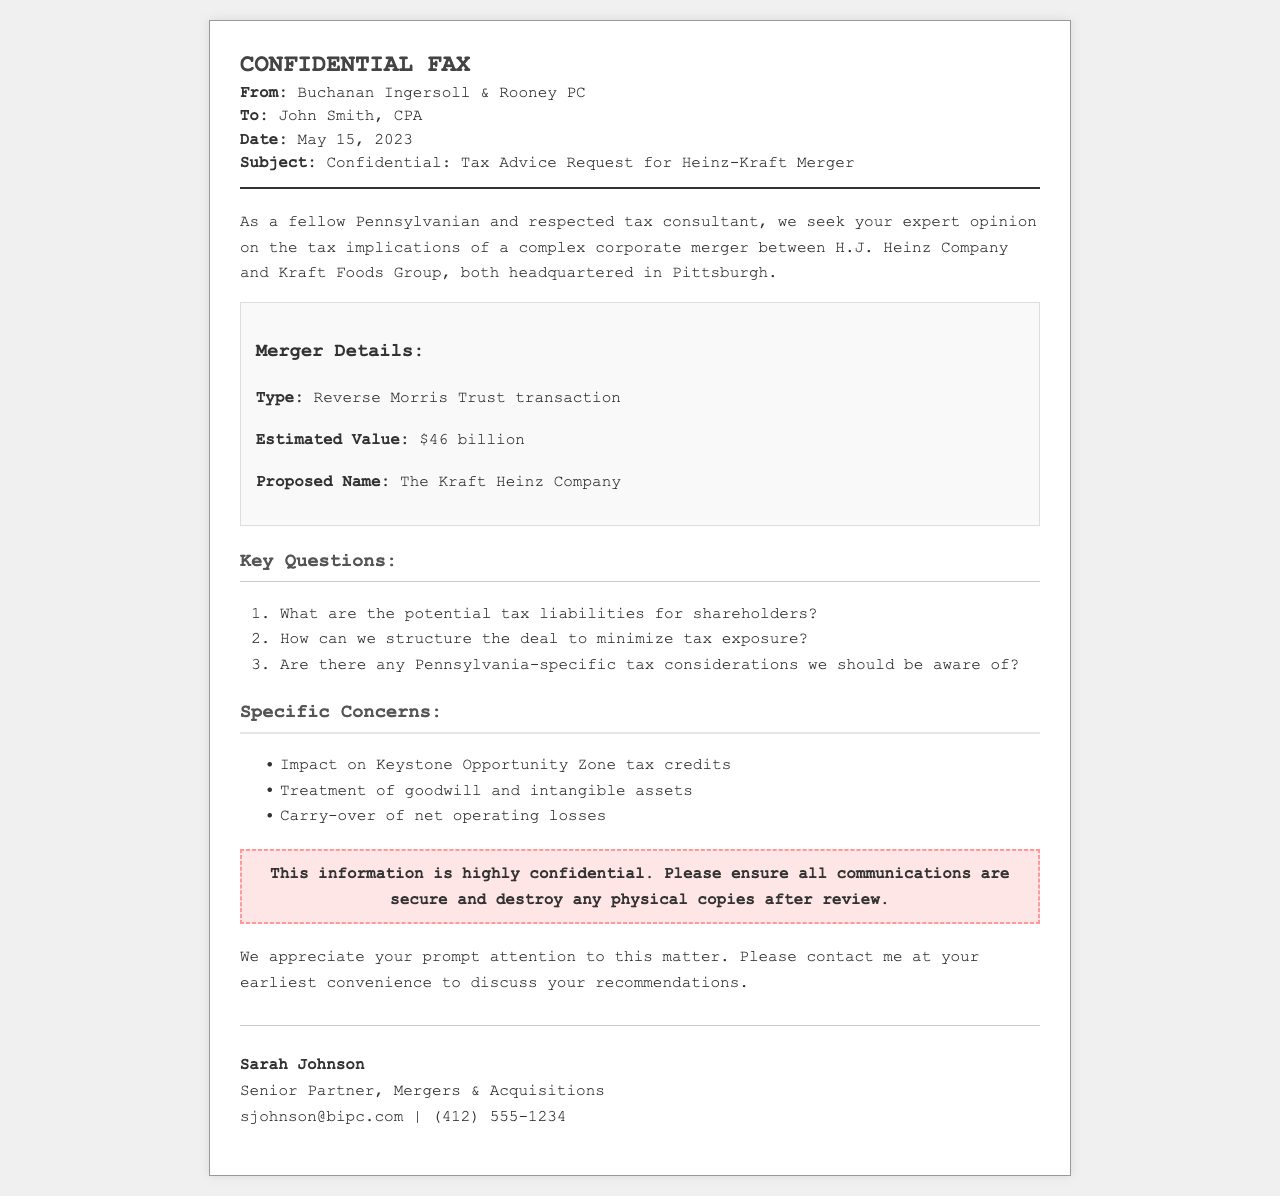What is the estimated value of the merger? The estimated value of the Heinz-Kraft merger is stated in the document.
Answer: $46 billion Who is the sender of the fax? The sender's name is provided at the top of the document.
Answer: Buchanan Ingersoll & Rooney PC What is the proposed name for the merged company? The proposed name is mentioned in the merger details section.
Answer: The Kraft Heinz Company What type of transaction is being discussed? The document specifies the type of transaction under merger details.
Answer: Reverse Morris Trust transaction What is one specific concern regarding tax? The document lists specific concerns related to the merger, including tax issues.
Answer: Impact on Keystone Opportunity Zone tax credits Who is the recipient of the fax? The recipient's name appears in the header of the document.
Answer: John Smith, CPA When was the fax sent? The date of the fax is mentioned in the header section of the document.
Answer: May 15, 2023 What is the title of the sender? The sender's title is included with the signature at the bottom of the document.
Answer: Senior Partner, Mergers & Acquisitions What is one key question asked in the document? The document outlines several key questions regarding the merger.
Answer: What are the potential tax liabilities for shareholders? 